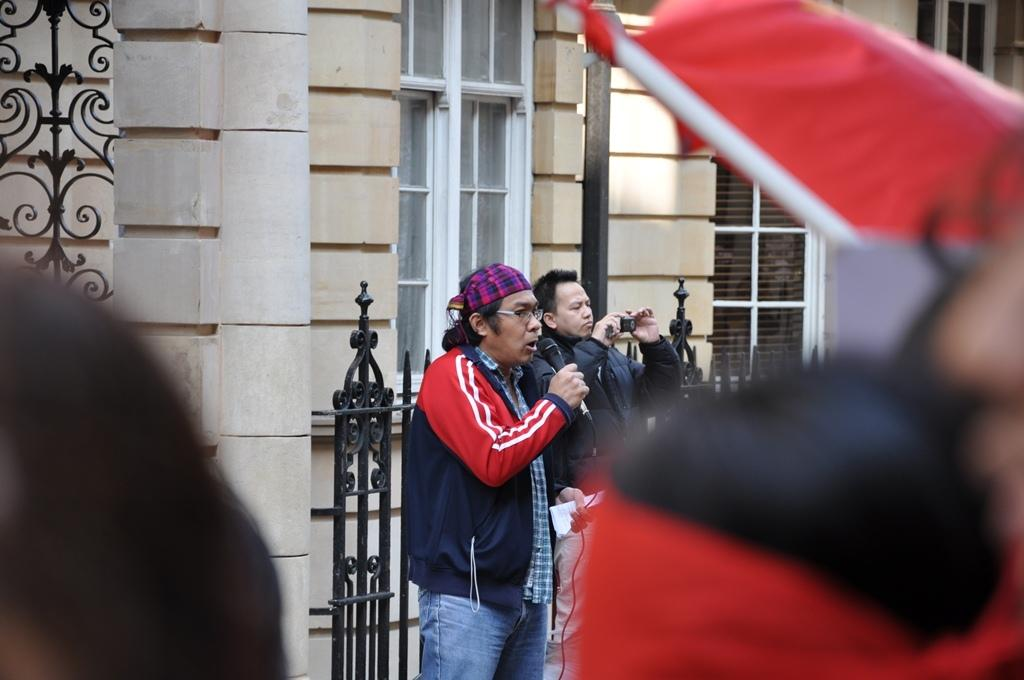What is the man in the image doing? The man is standing and singing in the image. What is the man holding while singing? The man is holding a microphone. What is the man wearing in the image? The man is wearing a coat. Who is standing beside the singing man? There is another man standing beside him. What is the second man holding? The second man is holding a mobile. What can be seen in the background of the image? There is a wall in the background of the image. How many minutes does the ship take to pass by in the image? There is no ship present in the image, so it is not possible to determine how many minutes it would take to pass by. 